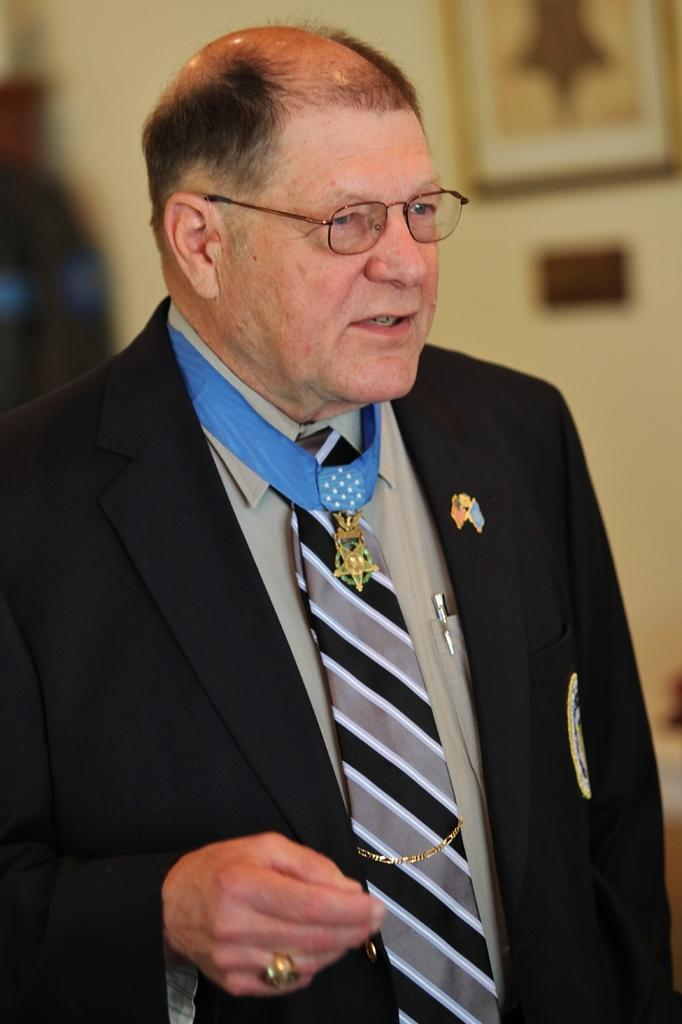Who is the main subject in the image? There is a person in the center of the image. What is the person wearing? The person is wearing a black suit and spectacles. What can be seen in the background of the image? There is a wall in the background of the image. Are there any objects on the wall? Yes, there is a photo frame on the wall. What type of cabbage is growing on the person's head in the image? There is no cabbage present in the image; the person is wearing a black suit and spectacles. What disease is the person suffering from in the image? There is no indication of any disease in the image; the person is simply wearing a black suit and spectacles. 